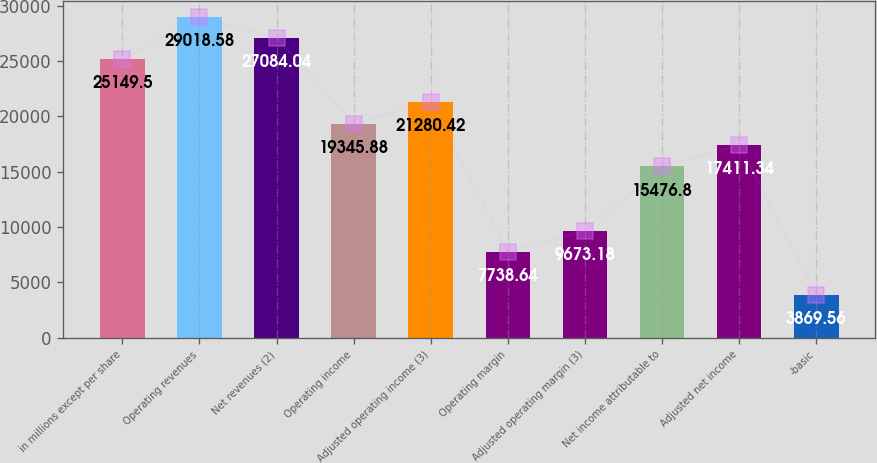Convert chart. <chart><loc_0><loc_0><loc_500><loc_500><bar_chart><fcel>in millions except per share<fcel>Operating revenues<fcel>Net revenues (2)<fcel>Operating income<fcel>Adjusted operating income (3)<fcel>Operating margin<fcel>Adjusted operating margin (3)<fcel>Net income attributable to<fcel>Adjusted net income<fcel>-basic<nl><fcel>25149.5<fcel>29018.6<fcel>27084<fcel>19345.9<fcel>21280.4<fcel>7738.64<fcel>9673.18<fcel>15476.8<fcel>17411.3<fcel>3869.56<nl></chart> 